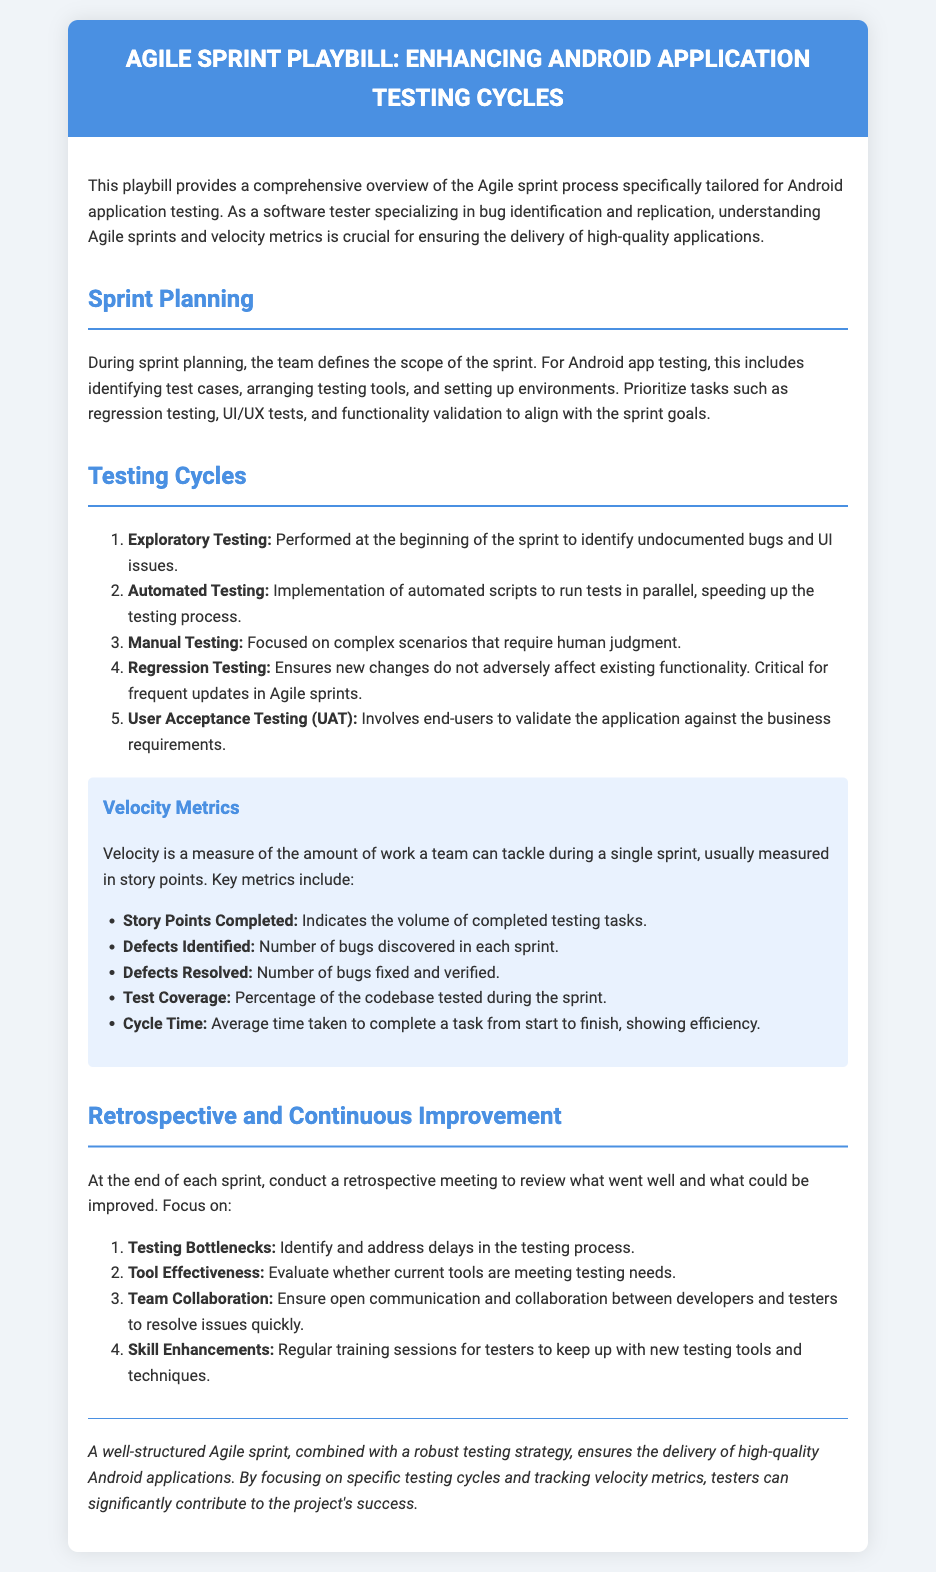What is the title of the playbill? The title of the playbill is found in the header section of the document.
Answer: Agile Sprint Playbill: Enhancing Android Application Testing How many types of testing cycles are mentioned? The document lists five different types of testing cycles.
Answer: 5 What is the purpose of User Acceptance Testing (UAT)? UAT is specifically mentioned as involving end-users to validate the application against business requirements.
Answer: Validate business requirements What is the key metric for measuring the amount of work done in a sprint? The document emphasizes that velocity is a measure of the work that can be tackled during a sprint, usually measured in story points.
Answer: Story points Which testing cycle is performed at the beginning of the sprint? The document clearly states that exploratory testing is conducted at the beginning of the sprint to identify undocumented bugs.
Answer: Exploratory Testing What is the focus of the retrospective meeting at the end of the sprint? The retrospective meeting focuses on reviewing what went well and identifying areas for improvement in the testing process.
Answer: Improvement What type of testing ensures that new changes do not adversely affect existing functionality? The document highlights regression testing as critical for ensuring that new changes don’t negatively impact existing functionality.
Answer: Regression Testing What area does the metrics section cover? The metrics section covers various velocity metrics related to the testing process in Agile sprints.
Answer: Velocity Metrics 